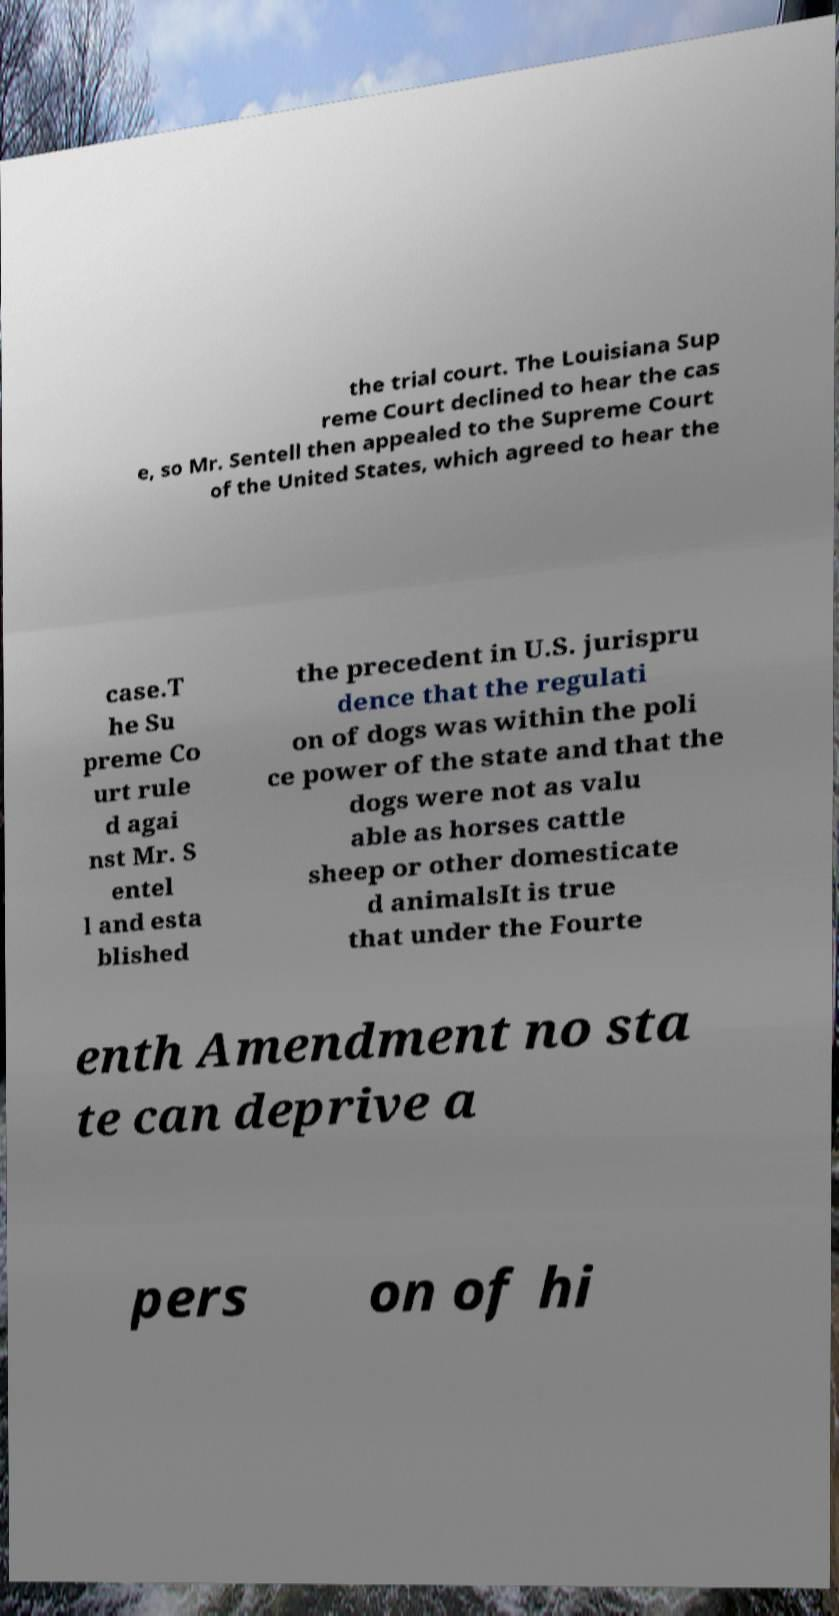Could you extract and type out the text from this image? the trial court. The Louisiana Sup reme Court declined to hear the cas e, so Mr. Sentell then appealed to the Supreme Court of the United States, which agreed to hear the case.T he Su preme Co urt rule d agai nst Mr. S entel l and esta blished the precedent in U.S. jurispru dence that the regulati on of dogs was within the poli ce power of the state and that the dogs were not as valu able as horses cattle sheep or other domesticate d animalsIt is true that under the Fourte enth Amendment no sta te can deprive a pers on of hi 